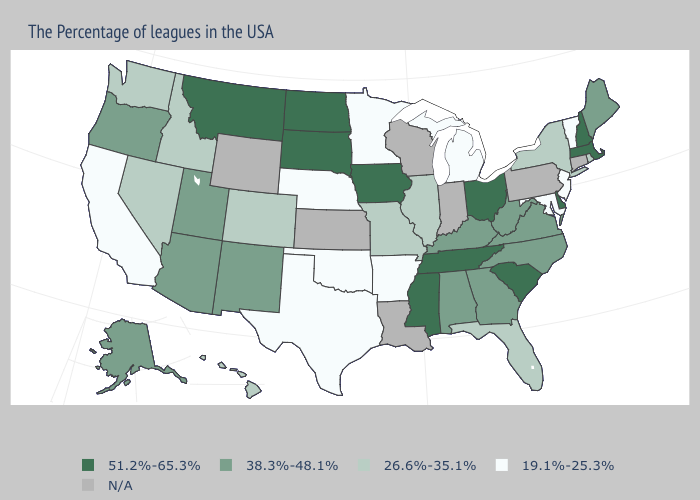Does the first symbol in the legend represent the smallest category?
Short answer required. No. Name the states that have a value in the range N/A?
Give a very brief answer. Connecticut, Pennsylvania, Indiana, Wisconsin, Louisiana, Kansas, Wyoming. Does Montana have the highest value in the USA?
Write a very short answer. Yes. Which states have the lowest value in the South?
Write a very short answer. Maryland, Arkansas, Oklahoma, Texas. How many symbols are there in the legend?
Quick response, please. 5. Name the states that have a value in the range 26.6%-35.1%?
Give a very brief answer. Rhode Island, New York, Florida, Illinois, Missouri, Colorado, Idaho, Nevada, Washington, Hawaii. What is the highest value in the USA?
Short answer required. 51.2%-65.3%. Name the states that have a value in the range N/A?
Be succinct. Connecticut, Pennsylvania, Indiana, Wisconsin, Louisiana, Kansas, Wyoming. Does the first symbol in the legend represent the smallest category?
Write a very short answer. No. What is the value of Utah?
Give a very brief answer. 38.3%-48.1%. Which states hav the highest value in the West?
Concise answer only. Montana. Among the states that border North Dakota , which have the lowest value?
Quick response, please. Minnesota. Does the first symbol in the legend represent the smallest category?
Short answer required. No. What is the value of South Dakota?
Concise answer only. 51.2%-65.3%. 